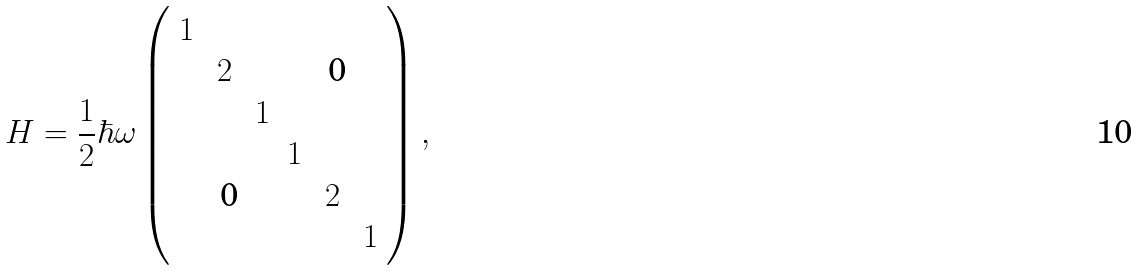Convert formula to latex. <formula><loc_0><loc_0><loc_500><loc_500>H = \frac { 1 } { 2 } \hbar { \omega } \left ( \begin{array} { c c c c c c } 1 & & & & & \\ & 2 & & & \text { 0} & \\ & & 1 & & & \\ & & & 1 & & \\ & \text { 0} & & & 2 & \\ & & & & & 1 \end{array} \right ) ,</formula> 